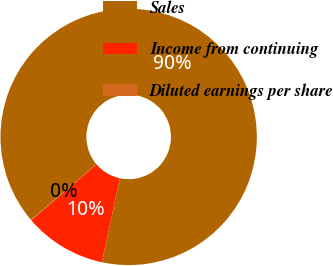<chart> <loc_0><loc_0><loc_500><loc_500><pie_chart><fcel>Sales<fcel>Income from continuing<fcel>Diluted earnings per share<nl><fcel>89.54%<fcel>10.4%<fcel>0.06%<nl></chart> 